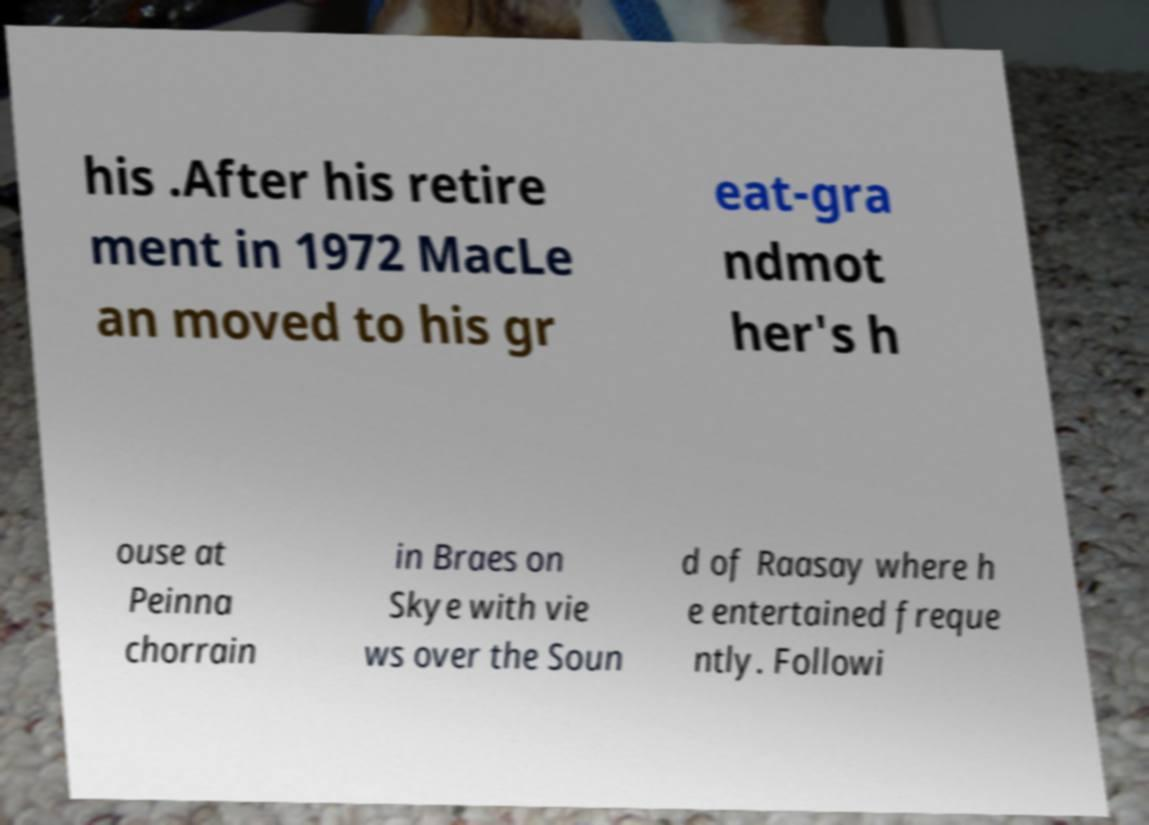Can you read and provide the text displayed in the image?This photo seems to have some interesting text. Can you extract and type it out for me? his .After his retire ment in 1972 MacLe an moved to his gr eat-gra ndmot her's h ouse at Peinna chorrain in Braes on Skye with vie ws over the Soun d of Raasay where h e entertained freque ntly. Followi 